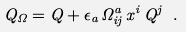Convert formula to latex. <formula><loc_0><loc_0><loc_500><loc_500>Q _ { \Omega } = Q + \epsilon _ { a } \, \Omega ^ { a } _ { i j } \, x ^ { i } \, Q ^ { j } \ .</formula> 